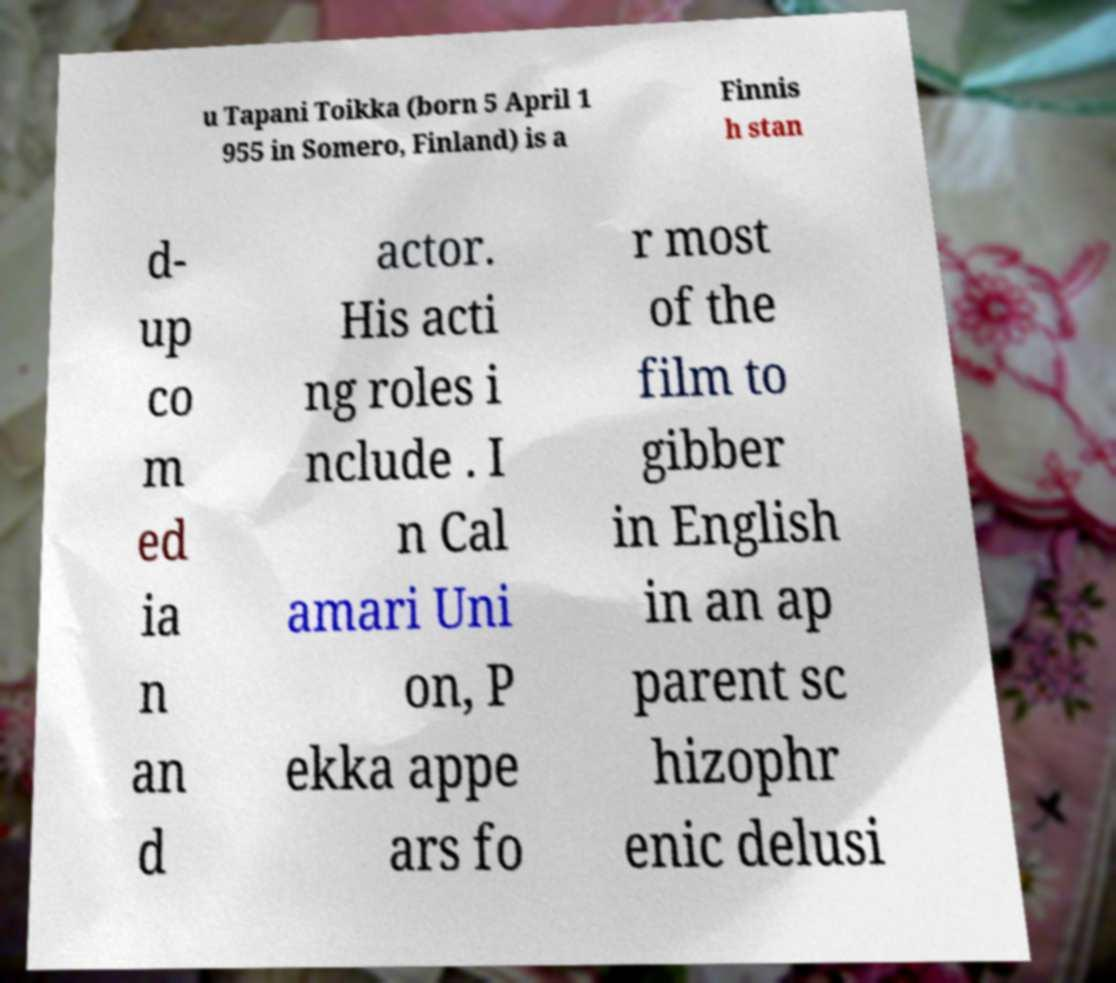Please identify and transcribe the text found in this image. u Tapani Toikka (born 5 April 1 955 in Somero, Finland) is a Finnis h stan d- up co m ed ia n an d actor. His acti ng roles i nclude . I n Cal amari Uni on, P ekka appe ars fo r most of the film to gibber in English in an ap parent sc hizophr enic delusi 